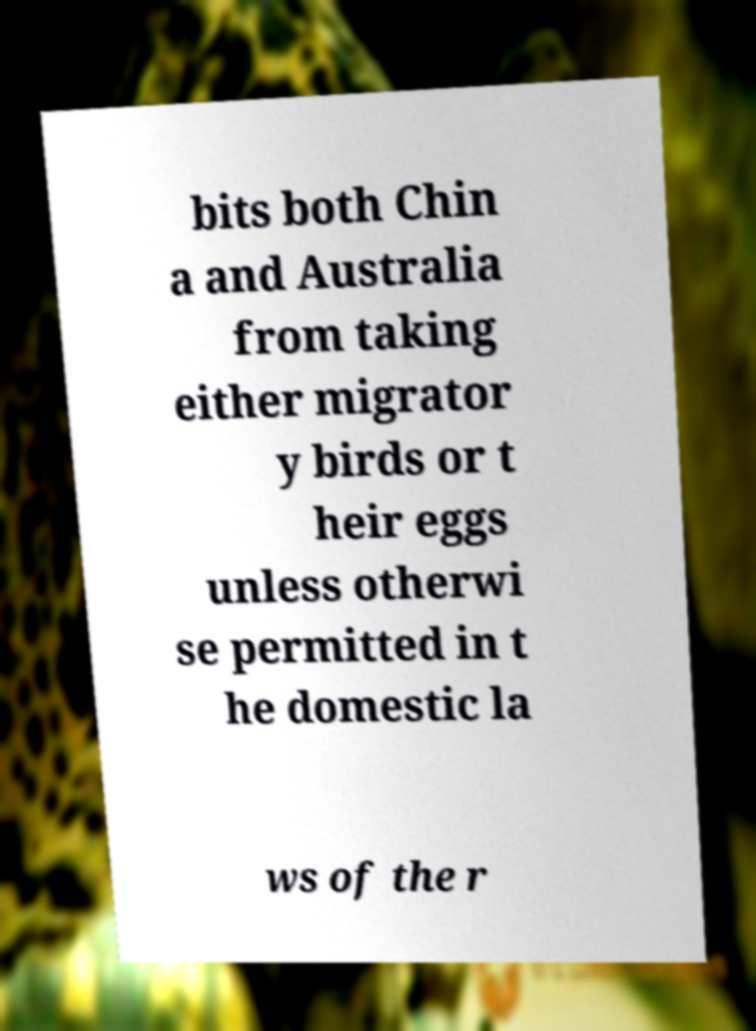Please read and relay the text visible in this image. What does it say? bits both Chin a and Australia from taking either migrator y birds or t heir eggs unless otherwi se permitted in t he domestic la ws of the r 